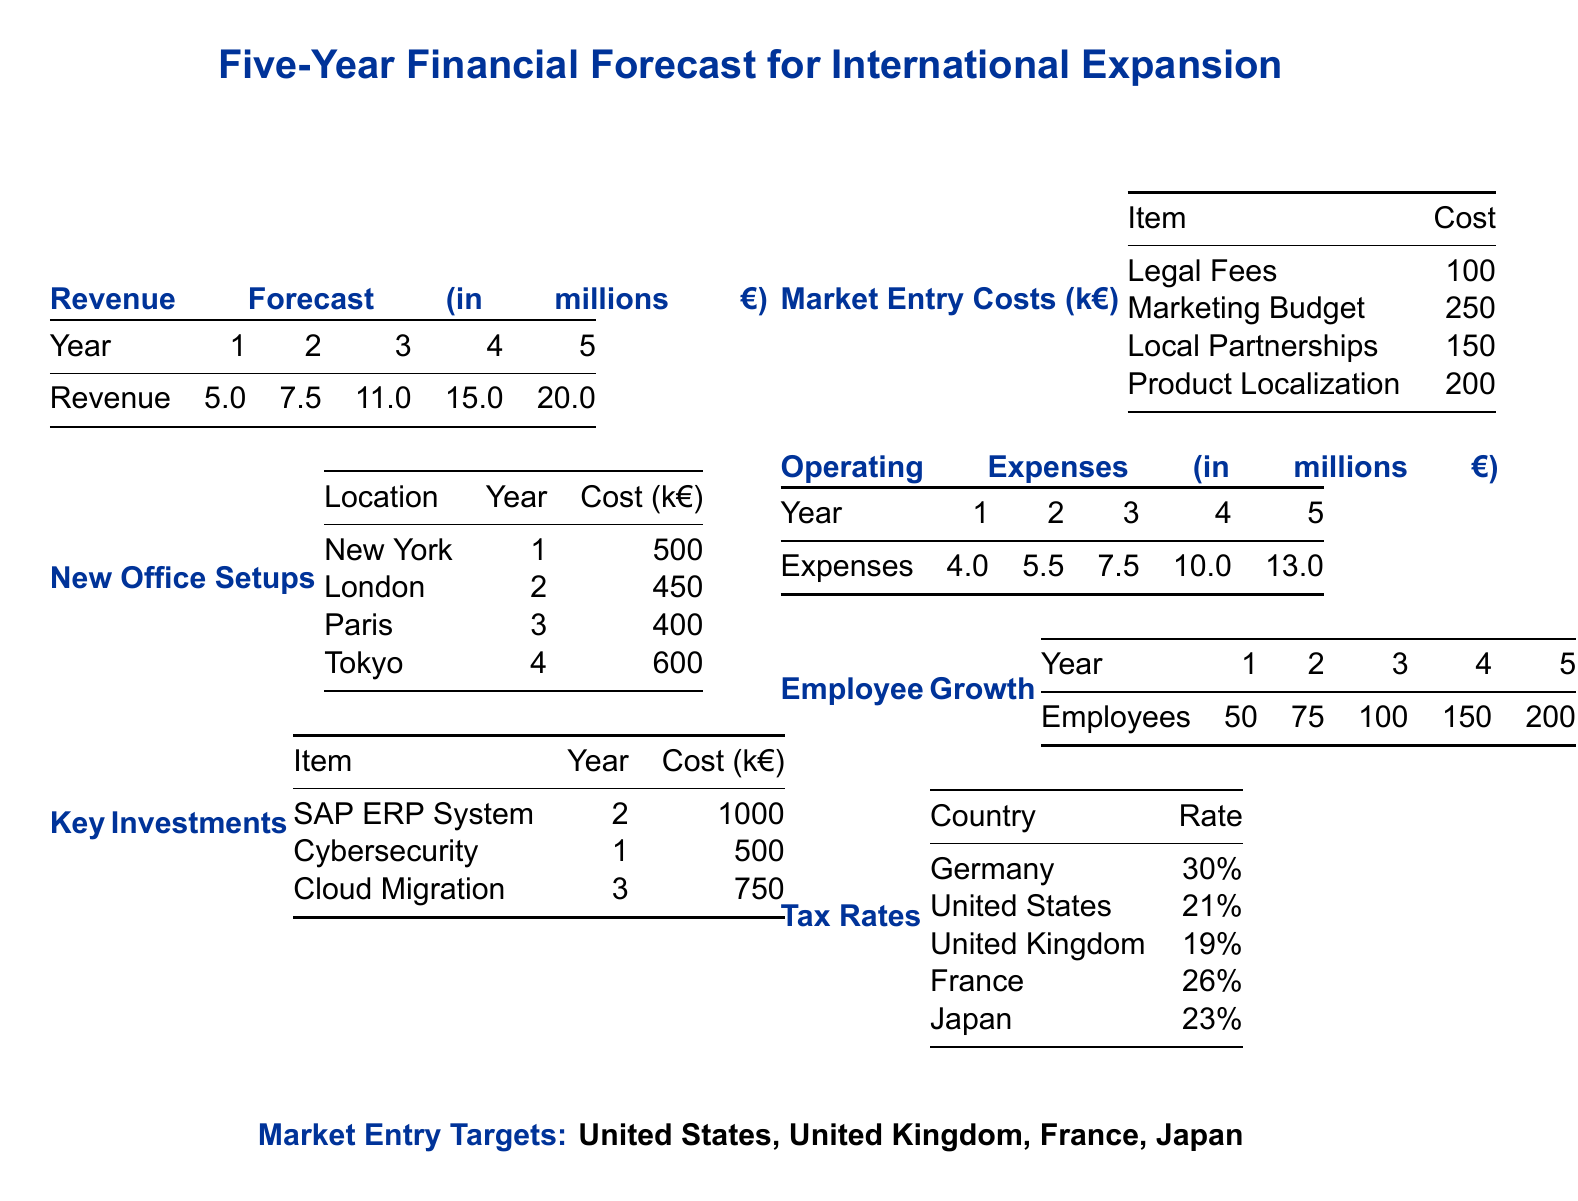What is the revenue in year 3? The revenue in year 3 is specified in the document and is listed in the revenue forecast table.
Answer: 11.0 How much will it cost to set up the office in London? The cost for the London office setup is shown in the "New Office Setups" table.
Answer: 450 k€ What are the key investments in year 2? The key investments for year 2 can be found in the "Key Investments" table.
Answer: SAP ERP System: 1000 k€; Cybersecurity: 500 k€ What is the total operating expense in year 5? The total operating expense for year 5 is found in the operating expenses table.
Answer: 13.0 How many employees are expected in year 4? The employee growth projections can be found in the "Employee Growth" table.
Answer: 150 What is the tax rate for France? The tax rates for various countries are listed in the "Tax Rates" table.
Answer: 26% What is the total market entry cost for Legal Fees and Marketing Budget? The total market entry costs for these items can be summed as listed in the "Market Entry Costs" table.
Answer: 350 k€ In which year is the Tokyo office setup planned? The office setup year for Tokyo is specified in the "New Office Setups" table.
Answer: 4 What is the total revenue forecast for all five years? The total revenue forecast can be calculated by summing the listed revenues from the revenue forecast table.
Answer: 58.5 What are the key market entry targets? The key market entry targets are mentioned at the end of the document.
Answer: United States, United Kingdom, France, Japan 